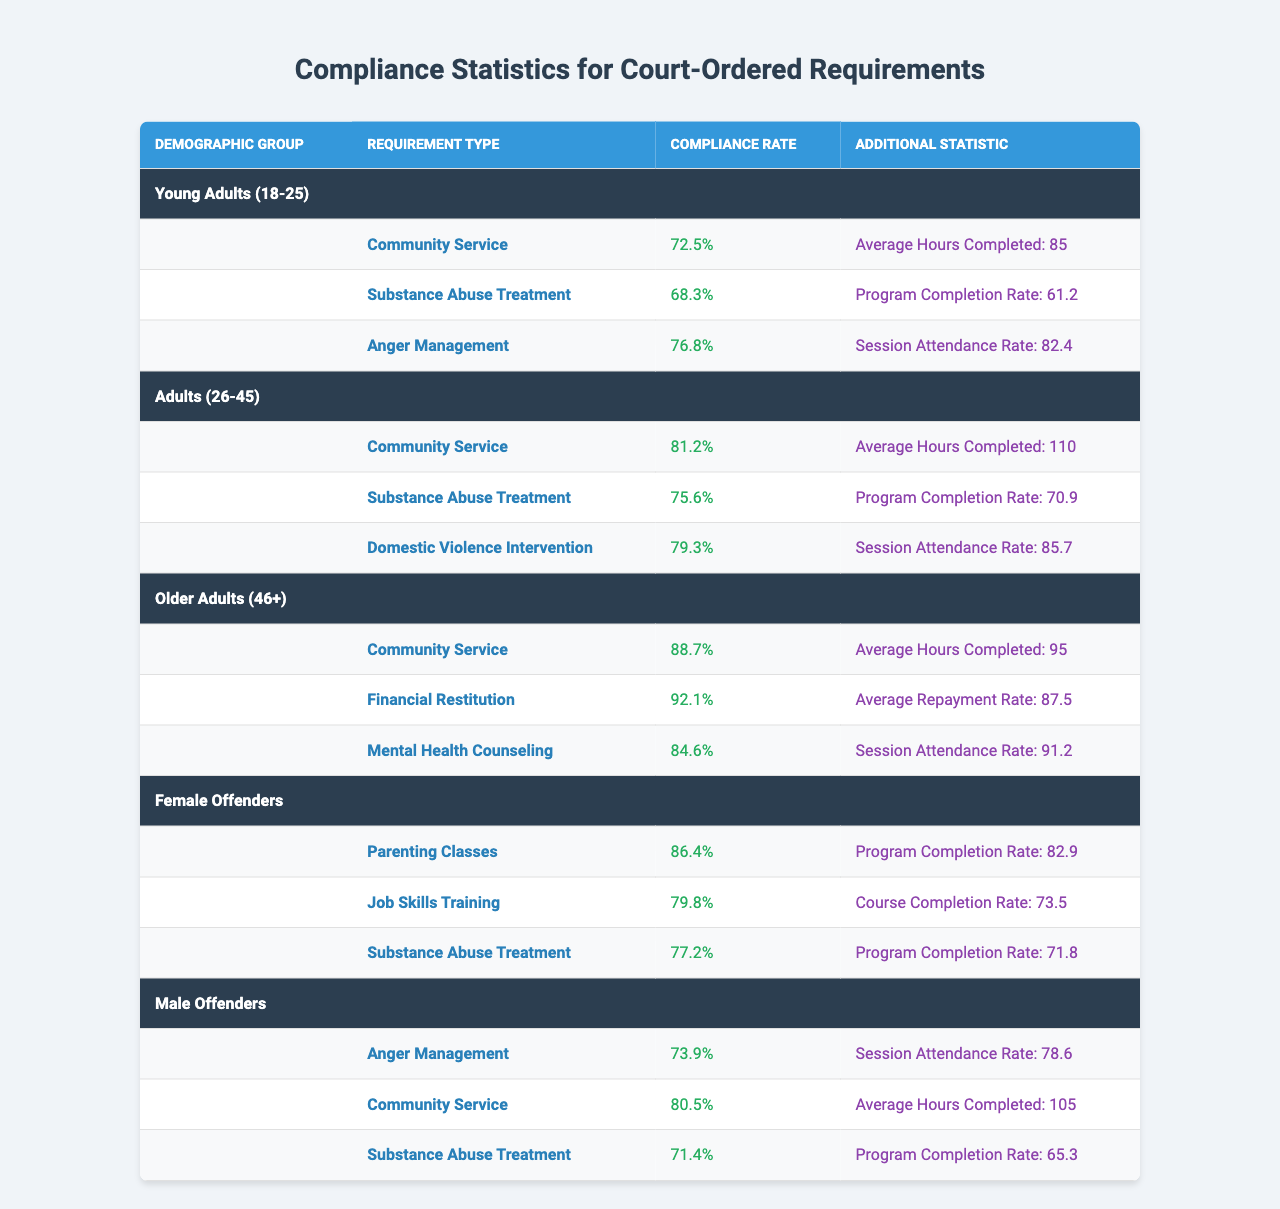What is the compliance rate for Substance Abuse Treatment among Young Adults? The table lists the compliance rate for Substance Abuse Treatment under the Young Adults demographic group as 68.3%.
Answer: 68.3% Which demographic group shows the highest compliance rate for Community Service? The table shows that Older Adults have the highest compliance rate for Community Service at 88.7%.
Answer: 88.7% What is the average hours completed for Community Service among Adults? The table indicates that Adults completed an average of 110 hours for Community Service.
Answer: 110 hours Is the compliance rate for Financial Restitution higher than 90% for any demographic group? Yes, the table shows that the compliance rate for Financial Restitution among Older Adults is 92.1%, which is above 90%.
Answer: Yes Which demographic group has the lowest compliance rate for Anger Management? By examining the table, we see that the Young Adults have a compliance rate of 76.8%, which is lower than that of Male Offenders at 73.9%. Therefore, Male Offenders have the lowest compliance rate for Anger Management.
Answer: Male Offenders What is the difference in compliance rate for Parenting Classes between Female Offenders and Substance Abuse Treatment for the same group? The compliance rate for Parenting Classes among Female Offenders is 86.4%, and for Substance Abuse Treatment, it is 77.2%. The difference is 86.4% - 77.2% = 9.2%.
Answer: 9.2% If we average the compliance rates for Community Service across all groups, what do we get? The compliance rates for Community Service are: Young Adults 72.5%, Adults 81.2%, Older Adults 88.7%, Female Offenders 80.5%, and Male Offenders 80.5%. The average is (72.5 + 81.2 + 88.7 + 86.4 + 80.5) / 5 = 81.86%.
Answer: 81.86% What is the highest program completion rate among the requirements listed? The highest program completion rate is for Financial Restitution among Older Adults, which is 87.5%.
Answer: 87.5% Do all demographic groups comply with the substance abuse treatment program above 70%? No, Male Offenders have a compliance rate of 71.4% for Substance Abuse Treatment, which is below the 70% threshold.
Answer: No Among Young Adults, how does the compliance rate for Anger Management compare to that of Substance Abuse Treatment? The compliance rate for Anger Management for Young Adults is 76.8%, while for Substance Abuse Treatment, it is 68.3%. Anger Management has a higher compliance rate by 8.5%.
Answer: Higher by 8.5% 